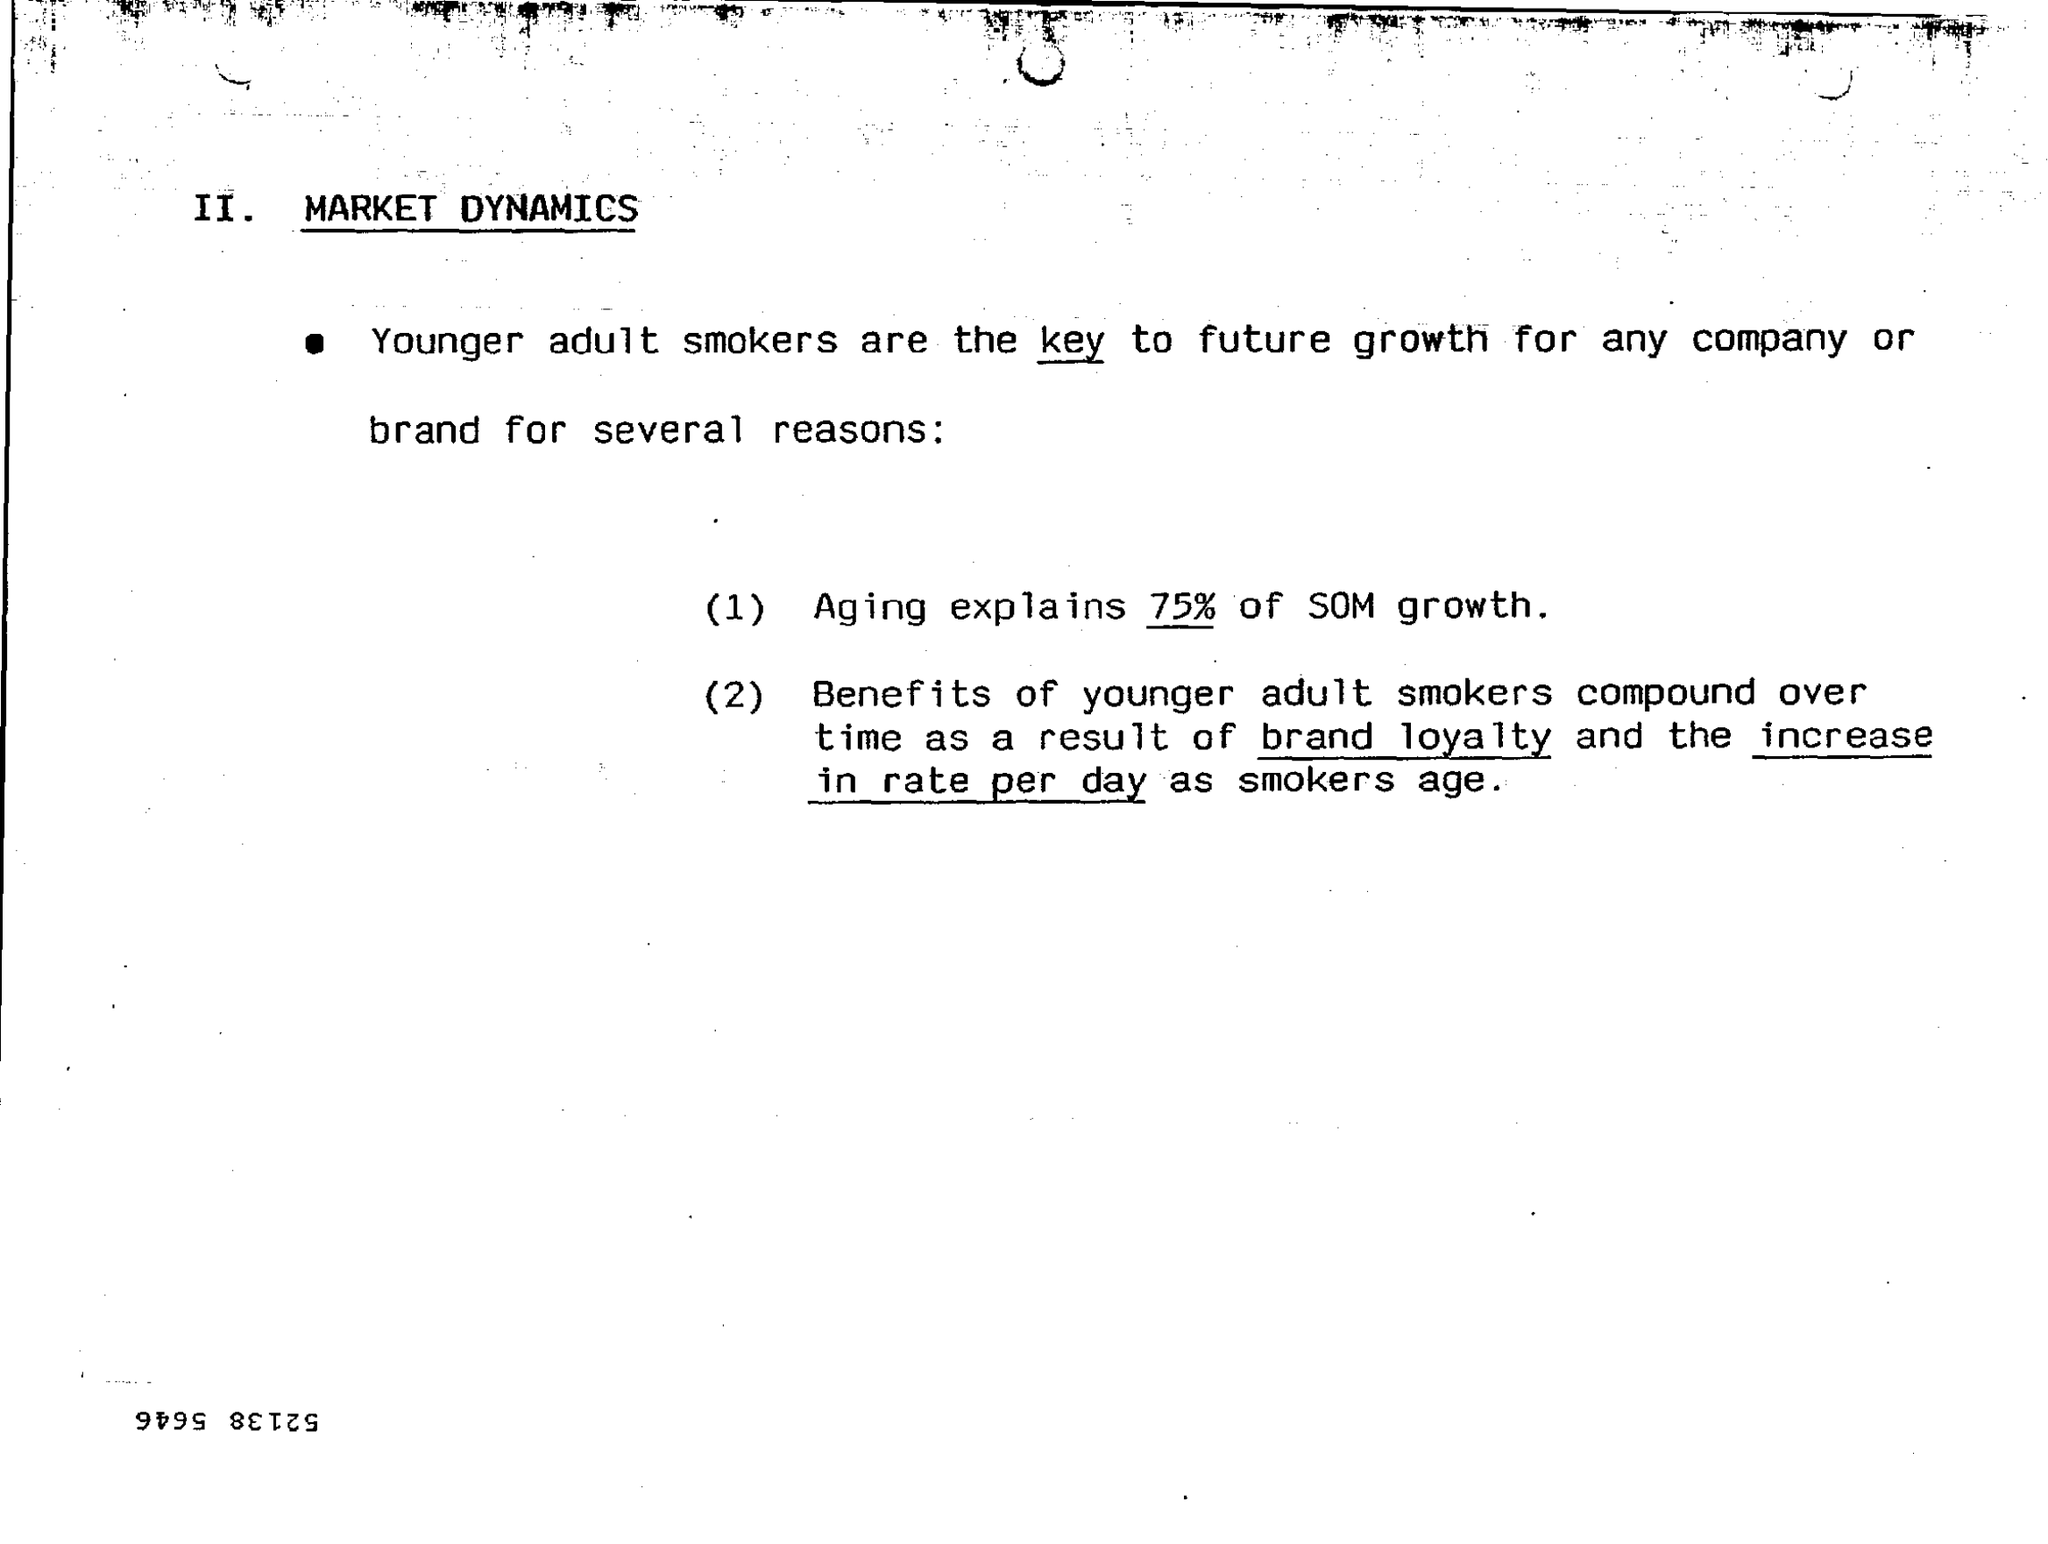Who are the key to future growth for any company or brand for several reasons ?
Your answer should be compact. Younger adult smokers. Aging explains how much % of SOM growth ?
Make the answer very short. 75%. 